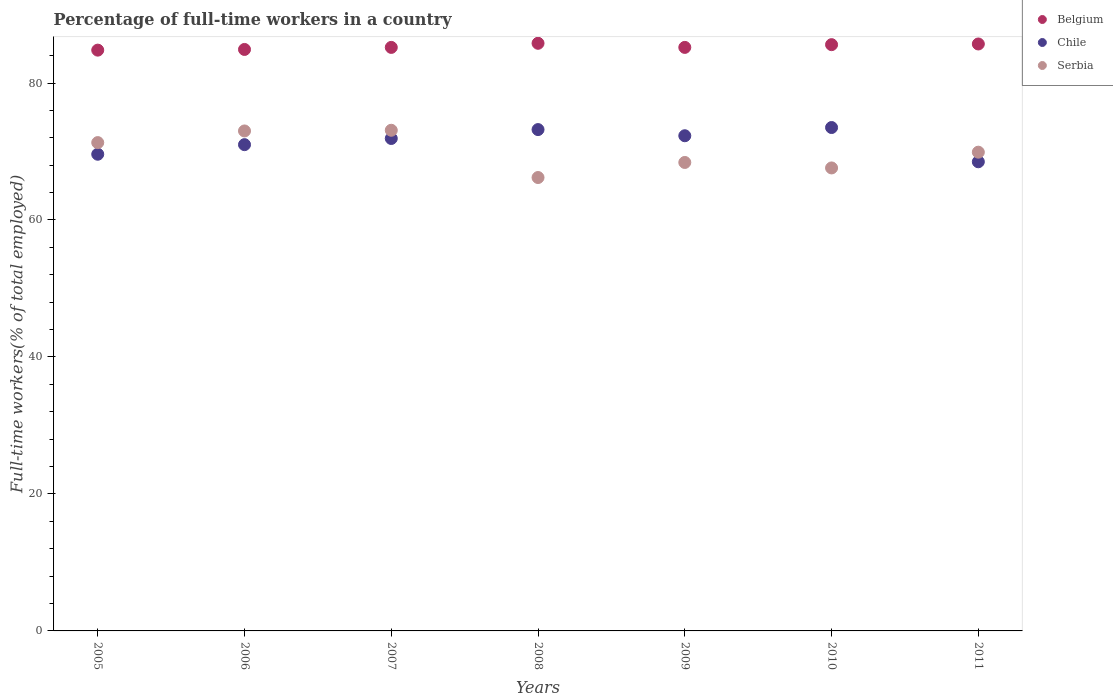How many different coloured dotlines are there?
Offer a very short reply. 3. Is the number of dotlines equal to the number of legend labels?
Provide a succinct answer. Yes. What is the percentage of full-time workers in Chile in 2005?
Offer a terse response. 69.6. Across all years, what is the maximum percentage of full-time workers in Serbia?
Offer a terse response. 73.1. Across all years, what is the minimum percentage of full-time workers in Serbia?
Offer a terse response. 66.2. In which year was the percentage of full-time workers in Serbia minimum?
Your answer should be very brief. 2008. What is the total percentage of full-time workers in Serbia in the graph?
Make the answer very short. 489.5. What is the difference between the percentage of full-time workers in Serbia in 2008 and that in 2010?
Your answer should be compact. -1.4. What is the difference between the percentage of full-time workers in Serbia in 2010 and the percentage of full-time workers in Chile in 2009?
Provide a succinct answer. -4.7. What is the average percentage of full-time workers in Serbia per year?
Offer a very short reply. 69.93. In the year 2006, what is the difference between the percentage of full-time workers in Belgium and percentage of full-time workers in Chile?
Offer a terse response. 13.9. What is the ratio of the percentage of full-time workers in Belgium in 2007 to that in 2009?
Offer a very short reply. 1. Is the difference between the percentage of full-time workers in Belgium in 2008 and 2009 greater than the difference between the percentage of full-time workers in Chile in 2008 and 2009?
Your response must be concise. No. What is the difference between the highest and the second highest percentage of full-time workers in Chile?
Give a very brief answer. 0.3. What is the difference between the highest and the lowest percentage of full-time workers in Serbia?
Provide a succinct answer. 6.9. In how many years, is the percentage of full-time workers in Belgium greater than the average percentage of full-time workers in Belgium taken over all years?
Offer a terse response. 3. How many years are there in the graph?
Your answer should be very brief. 7. Are the values on the major ticks of Y-axis written in scientific E-notation?
Your answer should be compact. No. Does the graph contain any zero values?
Offer a very short reply. No. Where does the legend appear in the graph?
Ensure brevity in your answer.  Top right. How are the legend labels stacked?
Offer a terse response. Vertical. What is the title of the graph?
Your answer should be compact. Percentage of full-time workers in a country. What is the label or title of the Y-axis?
Ensure brevity in your answer.  Full-time workers(% of total employed). What is the Full-time workers(% of total employed) of Belgium in 2005?
Make the answer very short. 84.8. What is the Full-time workers(% of total employed) of Chile in 2005?
Provide a succinct answer. 69.6. What is the Full-time workers(% of total employed) of Serbia in 2005?
Offer a very short reply. 71.3. What is the Full-time workers(% of total employed) of Belgium in 2006?
Keep it short and to the point. 84.9. What is the Full-time workers(% of total employed) of Serbia in 2006?
Your answer should be compact. 73. What is the Full-time workers(% of total employed) in Belgium in 2007?
Provide a short and direct response. 85.2. What is the Full-time workers(% of total employed) in Chile in 2007?
Provide a succinct answer. 71.9. What is the Full-time workers(% of total employed) of Serbia in 2007?
Keep it short and to the point. 73.1. What is the Full-time workers(% of total employed) in Belgium in 2008?
Your response must be concise. 85.8. What is the Full-time workers(% of total employed) of Chile in 2008?
Provide a succinct answer. 73.2. What is the Full-time workers(% of total employed) in Serbia in 2008?
Make the answer very short. 66.2. What is the Full-time workers(% of total employed) of Belgium in 2009?
Your response must be concise. 85.2. What is the Full-time workers(% of total employed) of Chile in 2009?
Offer a very short reply. 72.3. What is the Full-time workers(% of total employed) of Serbia in 2009?
Make the answer very short. 68.4. What is the Full-time workers(% of total employed) of Belgium in 2010?
Your response must be concise. 85.6. What is the Full-time workers(% of total employed) of Chile in 2010?
Your answer should be very brief. 73.5. What is the Full-time workers(% of total employed) of Serbia in 2010?
Your answer should be very brief. 67.6. What is the Full-time workers(% of total employed) in Belgium in 2011?
Provide a succinct answer. 85.7. What is the Full-time workers(% of total employed) in Chile in 2011?
Your response must be concise. 68.5. What is the Full-time workers(% of total employed) of Serbia in 2011?
Provide a short and direct response. 69.9. Across all years, what is the maximum Full-time workers(% of total employed) in Belgium?
Keep it short and to the point. 85.8. Across all years, what is the maximum Full-time workers(% of total employed) of Chile?
Provide a short and direct response. 73.5. Across all years, what is the maximum Full-time workers(% of total employed) of Serbia?
Ensure brevity in your answer.  73.1. Across all years, what is the minimum Full-time workers(% of total employed) of Belgium?
Make the answer very short. 84.8. Across all years, what is the minimum Full-time workers(% of total employed) of Chile?
Your response must be concise. 68.5. Across all years, what is the minimum Full-time workers(% of total employed) of Serbia?
Provide a succinct answer. 66.2. What is the total Full-time workers(% of total employed) of Belgium in the graph?
Ensure brevity in your answer.  597.2. What is the total Full-time workers(% of total employed) of Chile in the graph?
Ensure brevity in your answer.  500. What is the total Full-time workers(% of total employed) in Serbia in the graph?
Your answer should be very brief. 489.5. What is the difference between the Full-time workers(% of total employed) in Belgium in 2005 and that in 2007?
Offer a terse response. -0.4. What is the difference between the Full-time workers(% of total employed) in Serbia in 2005 and that in 2007?
Provide a short and direct response. -1.8. What is the difference between the Full-time workers(% of total employed) in Chile in 2005 and that in 2008?
Keep it short and to the point. -3.6. What is the difference between the Full-time workers(% of total employed) of Serbia in 2005 and that in 2008?
Keep it short and to the point. 5.1. What is the difference between the Full-time workers(% of total employed) of Belgium in 2005 and that in 2009?
Make the answer very short. -0.4. What is the difference between the Full-time workers(% of total employed) of Belgium in 2005 and that in 2010?
Your answer should be compact. -0.8. What is the difference between the Full-time workers(% of total employed) of Chile in 2005 and that in 2010?
Your answer should be compact. -3.9. What is the difference between the Full-time workers(% of total employed) in Belgium in 2005 and that in 2011?
Your response must be concise. -0.9. What is the difference between the Full-time workers(% of total employed) of Belgium in 2006 and that in 2007?
Give a very brief answer. -0.3. What is the difference between the Full-time workers(% of total employed) of Chile in 2006 and that in 2007?
Offer a terse response. -0.9. What is the difference between the Full-time workers(% of total employed) of Belgium in 2006 and that in 2008?
Make the answer very short. -0.9. What is the difference between the Full-time workers(% of total employed) of Serbia in 2006 and that in 2008?
Offer a terse response. 6.8. What is the difference between the Full-time workers(% of total employed) in Belgium in 2006 and that in 2010?
Provide a succinct answer. -0.7. What is the difference between the Full-time workers(% of total employed) of Serbia in 2006 and that in 2010?
Provide a succinct answer. 5.4. What is the difference between the Full-time workers(% of total employed) of Belgium in 2006 and that in 2011?
Keep it short and to the point. -0.8. What is the difference between the Full-time workers(% of total employed) of Chile in 2006 and that in 2011?
Ensure brevity in your answer.  2.5. What is the difference between the Full-time workers(% of total employed) in Serbia in 2006 and that in 2011?
Your answer should be very brief. 3.1. What is the difference between the Full-time workers(% of total employed) of Belgium in 2007 and that in 2008?
Your answer should be very brief. -0.6. What is the difference between the Full-time workers(% of total employed) in Chile in 2007 and that in 2008?
Offer a terse response. -1.3. What is the difference between the Full-time workers(% of total employed) in Belgium in 2007 and that in 2009?
Your answer should be compact. 0. What is the difference between the Full-time workers(% of total employed) of Belgium in 2007 and that in 2010?
Your answer should be compact. -0.4. What is the difference between the Full-time workers(% of total employed) in Belgium in 2007 and that in 2011?
Provide a succinct answer. -0.5. What is the difference between the Full-time workers(% of total employed) in Chile in 2008 and that in 2009?
Offer a very short reply. 0.9. What is the difference between the Full-time workers(% of total employed) of Belgium in 2008 and that in 2010?
Offer a very short reply. 0.2. What is the difference between the Full-time workers(% of total employed) of Serbia in 2008 and that in 2010?
Provide a short and direct response. -1.4. What is the difference between the Full-time workers(% of total employed) of Belgium in 2009 and that in 2010?
Provide a short and direct response. -0.4. What is the difference between the Full-time workers(% of total employed) in Chile in 2009 and that in 2010?
Offer a terse response. -1.2. What is the difference between the Full-time workers(% of total employed) of Belgium in 2009 and that in 2011?
Make the answer very short. -0.5. What is the difference between the Full-time workers(% of total employed) of Chile in 2009 and that in 2011?
Provide a succinct answer. 3.8. What is the difference between the Full-time workers(% of total employed) of Serbia in 2009 and that in 2011?
Your response must be concise. -1.5. What is the difference between the Full-time workers(% of total employed) of Belgium in 2010 and that in 2011?
Provide a succinct answer. -0.1. What is the difference between the Full-time workers(% of total employed) in Belgium in 2005 and the Full-time workers(% of total employed) in Chile in 2006?
Provide a short and direct response. 13.8. What is the difference between the Full-time workers(% of total employed) in Belgium in 2005 and the Full-time workers(% of total employed) in Serbia in 2006?
Give a very brief answer. 11.8. What is the difference between the Full-time workers(% of total employed) in Belgium in 2005 and the Full-time workers(% of total employed) in Serbia in 2008?
Offer a very short reply. 18.6. What is the difference between the Full-time workers(% of total employed) in Chile in 2005 and the Full-time workers(% of total employed) in Serbia in 2008?
Offer a terse response. 3.4. What is the difference between the Full-time workers(% of total employed) in Belgium in 2005 and the Full-time workers(% of total employed) in Chile in 2009?
Offer a very short reply. 12.5. What is the difference between the Full-time workers(% of total employed) in Belgium in 2005 and the Full-time workers(% of total employed) in Serbia in 2009?
Make the answer very short. 16.4. What is the difference between the Full-time workers(% of total employed) of Chile in 2005 and the Full-time workers(% of total employed) of Serbia in 2009?
Provide a succinct answer. 1.2. What is the difference between the Full-time workers(% of total employed) of Chile in 2005 and the Full-time workers(% of total employed) of Serbia in 2011?
Provide a short and direct response. -0.3. What is the difference between the Full-time workers(% of total employed) of Belgium in 2006 and the Full-time workers(% of total employed) of Chile in 2007?
Your answer should be compact. 13. What is the difference between the Full-time workers(% of total employed) in Belgium in 2006 and the Full-time workers(% of total employed) in Serbia in 2007?
Ensure brevity in your answer.  11.8. What is the difference between the Full-time workers(% of total employed) of Chile in 2006 and the Full-time workers(% of total employed) of Serbia in 2007?
Keep it short and to the point. -2.1. What is the difference between the Full-time workers(% of total employed) of Belgium in 2006 and the Full-time workers(% of total employed) of Chile in 2008?
Your response must be concise. 11.7. What is the difference between the Full-time workers(% of total employed) in Belgium in 2006 and the Full-time workers(% of total employed) in Serbia in 2008?
Provide a short and direct response. 18.7. What is the difference between the Full-time workers(% of total employed) of Chile in 2006 and the Full-time workers(% of total employed) of Serbia in 2008?
Your response must be concise. 4.8. What is the difference between the Full-time workers(% of total employed) of Belgium in 2006 and the Full-time workers(% of total employed) of Serbia in 2009?
Your answer should be compact. 16.5. What is the difference between the Full-time workers(% of total employed) in Belgium in 2006 and the Full-time workers(% of total employed) in Chile in 2010?
Offer a very short reply. 11.4. What is the difference between the Full-time workers(% of total employed) of Belgium in 2006 and the Full-time workers(% of total employed) of Serbia in 2010?
Provide a succinct answer. 17.3. What is the difference between the Full-time workers(% of total employed) of Chile in 2006 and the Full-time workers(% of total employed) of Serbia in 2010?
Give a very brief answer. 3.4. What is the difference between the Full-time workers(% of total employed) in Belgium in 2006 and the Full-time workers(% of total employed) in Chile in 2011?
Provide a succinct answer. 16.4. What is the difference between the Full-time workers(% of total employed) of Belgium in 2006 and the Full-time workers(% of total employed) of Serbia in 2011?
Offer a terse response. 15. What is the difference between the Full-time workers(% of total employed) in Chile in 2006 and the Full-time workers(% of total employed) in Serbia in 2011?
Your answer should be compact. 1.1. What is the difference between the Full-time workers(% of total employed) of Belgium in 2007 and the Full-time workers(% of total employed) of Chile in 2008?
Your answer should be compact. 12. What is the difference between the Full-time workers(% of total employed) of Belgium in 2007 and the Full-time workers(% of total employed) of Serbia in 2009?
Provide a succinct answer. 16.8. What is the difference between the Full-time workers(% of total employed) of Chile in 2007 and the Full-time workers(% of total employed) of Serbia in 2010?
Give a very brief answer. 4.3. What is the difference between the Full-time workers(% of total employed) in Belgium in 2008 and the Full-time workers(% of total employed) in Serbia in 2009?
Your answer should be very brief. 17.4. What is the difference between the Full-time workers(% of total employed) in Belgium in 2008 and the Full-time workers(% of total employed) in Chile in 2011?
Make the answer very short. 17.3. What is the difference between the Full-time workers(% of total employed) of Chile in 2008 and the Full-time workers(% of total employed) of Serbia in 2011?
Offer a terse response. 3.3. What is the difference between the Full-time workers(% of total employed) in Belgium in 2009 and the Full-time workers(% of total employed) in Chile in 2010?
Your answer should be compact. 11.7. What is the difference between the Full-time workers(% of total employed) in Belgium in 2009 and the Full-time workers(% of total employed) in Serbia in 2011?
Make the answer very short. 15.3. What is the difference between the Full-time workers(% of total employed) of Chile in 2010 and the Full-time workers(% of total employed) of Serbia in 2011?
Ensure brevity in your answer.  3.6. What is the average Full-time workers(% of total employed) of Belgium per year?
Your answer should be compact. 85.31. What is the average Full-time workers(% of total employed) of Chile per year?
Provide a short and direct response. 71.43. What is the average Full-time workers(% of total employed) in Serbia per year?
Your answer should be compact. 69.93. In the year 2005, what is the difference between the Full-time workers(% of total employed) in Chile and Full-time workers(% of total employed) in Serbia?
Provide a succinct answer. -1.7. In the year 2006, what is the difference between the Full-time workers(% of total employed) of Belgium and Full-time workers(% of total employed) of Serbia?
Make the answer very short. 11.9. In the year 2008, what is the difference between the Full-time workers(% of total employed) of Belgium and Full-time workers(% of total employed) of Chile?
Your answer should be compact. 12.6. In the year 2008, what is the difference between the Full-time workers(% of total employed) in Belgium and Full-time workers(% of total employed) in Serbia?
Offer a very short reply. 19.6. In the year 2009, what is the difference between the Full-time workers(% of total employed) of Chile and Full-time workers(% of total employed) of Serbia?
Offer a very short reply. 3.9. In the year 2010, what is the difference between the Full-time workers(% of total employed) in Belgium and Full-time workers(% of total employed) in Chile?
Offer a terse response. 12.1. In the year 2010, what is the difference between the Full-time workers(% of total employed) of Belgium and Full-time workers(% of total employed) of Serbia?
Make the answer very short. 18. In the year 2011, what is the difference between the Full-time workers(% of total employed) of Belgium and Full-time workers(% of total employed) of Chile?
Your answer should be very brief. 17.2. What is the ratio of the Full-time workers(% of total employed) in Belgium in 2005 to that in 2006?
Ensure brevity in your answer.  1. What is the ratio of the Full-time workers(% of total employed) in Chile in 2005 to that in 2006?
Your answer should be compact. 0.98. What is the ratio of the Full-time workers(% of total employed) in Serbia in 2005 to that in 2006?
Your response must be concise. 0.98. What is the ratio of the Full-time workers(% of total employed) of Belgium in 2005 to that in 2007?
Provide a short and direct response. 1. What is the ratio of the Full-time workers(% of total employed) in Serbia in 2005 to that in 2007?
Provide a succinct answer. 0.98. What is the ratio of the Full-time workers(% of total employed) of Belgium in 2005 to that in 2008?
Your response must be concise. 0.99. What is the ratio of the Full-time workers(% of total employed) in Chile in 2005 to that in 2008?
Your answer should be compact. 0.95. What is the ratio of the Full-time workers(% of total employed) in Serbia in 2005 to that in 2008?
Your answer should be compact. 1.08. What is the ratio of the Full-time workers(% of total employed) of Chile in 2005 to that in 2009?
Offer a terse response. 0.96. What is the ratio of the Full-time workers(% of total employed) in Serbia in 2005 to that in 2009?
Offer a terse response. 1.04. What is the ratio of the Full-time workers(% of total employed) in Belgium in 2005 to that in 2010?
Your answer should be compact. 0.99. What is the ratio of the Full-time workers(% of total employed) of Chile in 2005 to that in 2010?
Keep it short and to the point. 0.95. What is the ratio of the Full-time workers(% of total employed) in Serbia in 2005 to that in 2010?
Your answer should be compact. 1.05. What is the ratio of the Full-time workers(% of total employed) of Belgium in 2005 to that in 2011?
Give a very brief answer. 0.99. What is the ratio of the Full-time workers(% of total employed) of Chile in 2005 to that in 2011?
Your answer should be compact. 1.02. What is the ratio of the Full-time workers(% of total employed) in Belgium in 2006 to that in 2007?
Keep it short and to the point. 1. What is the ratio of the Full-time workers(% of total employed) in Chile in 2006 to that in 2007?
Make the answer very short. 0.99. What is the ratio of the Full-time workers(% of total employed) in Chile in 2006 to that in 2008?
Provide a short and direct response. 0.97. What is the ratio of the Full-time workers(% of total employed) of Serbia in 2006 to that in 2008?
Provide a short and direct response. 1.1. What is the ratio of the Full-time workers(% of total employed) in Belgium in 2006 to that in 2009?
Your answer should be very brief. 1. What is the ratio of the Full-time workers(% of total employed) in Serbia in 2006 to that in 2009?
Make the answer very short. 1.07. What is the ratio of the Full-time workers(% of total employed) in Chile in 2006 to that in 2010?
Your answer should be very brief. 0.97. What is the ratio of the Full-time workers(% of total employed) in Serbia in 2006 to that in 2010?
Provide a short and direct response. 1.08. What is the ratio of the Full-time workers(% of total employed) in Belgium in 2006 to that in 2011?
Your answer should be very brief. 0.99. What is the ratio of the Full-time workers(% of total employed) in Chile in 2006 to that in 2011?
Keep it short and to the point. 1.04. What is the ratio of the Full-time workers(% of total employed) in Serbia in 2006 to that in 2011?
Provide a succinct answer. 1.04. What is the ratio of the Full-time workers(% of total employed) of Chile in 2007 to that in 2008?
Ensure brevity in your answer.  0.98. What is the ratio of the Full-time workers(% of total employed) of Serbia in 2007 to that in 2008?
Offer a very short reply. 1.1. What is the ratio of the Full-time workers(% of total employed) in Chile in 2007 to that in 2009?
Your answer should be very brief. 0.99. What is the ratio of the Full-time workers(% of total employed) of Serbia in 2007 to that in 2009?
Your response must be concise. 1.07. What is the ratio of the Full-time workers(% of total employed) in Chile in 2007 to that in 2010?
Ensure brevity in your answer.  0.98. What is the ratio of the Full-time workers(% of total employed) in Serbia in 2007 to that in 2010?
Offer a very short reply. 1.08. What is the ratio of the Full-time workers(% of total employed) in Chile in 2007 to that in 2011?
Make the answer very short. 1.05. What is the ratio of the Full-time workers(% of total employed) in Serbia in 2007 to that in 2011?
Provide a short and direct response. 1.05. What is the ratio of the Full-time workers(% of total employed) of Belgium in 2008 to that in 2009?
Make the answer very short. 1.01. What is the ratio of the Full-time workers(% of total employed) in Chile in 2008 to that in 2009?
Offer a terse response. 1.01. What is the ratio of the Full-time workers(% of total employed) in Serbia in 2008 to that in 2009?
Offer a very short reply. 0.97. What is the ratio of the Full-time workers(% of total employed) of Belgium in 2008 to that in 2010?
Your answer should be very brief. 1. What is the ratio of the Full-time workers(% of total employed) of Chile in 2008 to that in 2010?
Provide a short and direct response. 1. What is the ratio of the Full-time workers(% of total employed) in Serbia in 2008 to that in 2010?
Provide a short and direct response. 0.98. What is the ratio of the Full-time workers(% of total employed) of Belgium in 2008 to that in 2011?
Offer a terse response. 1. What is the ratio of the Full-time workers(% of total employed) in Chile in 2008 to that in 2011?
Your answer should be compact. 1.07. What is the ratio of the Full-time workers(% of total employed) of Serbia in 2008 to that in 2011?
Your answer should be compact. 0.95. What is the ratio of the Full-time workers(% of total employed) of Chile in 2009 to that in 2010?
Ensure brevity in your answer.  0.98. What is the ratio of the Full-time workers(% of total employed) of Serbia in 2009 to that in 2010?
Your answer should be compact. 1.01. What is the ratio of the Full-time workers(% of total employed) in Belgium in 2009 to that in 2011?
Provide a short and direct response. 0.99. What is the ratio of the Full-time workers(% of total employed) of Chile in 2009 to that in 2011?
Give a very brief answer. 1.06. What is the ratio of the Full-time workers(% of total employed) in Serbia in 2009 to that in 2011?
Your answer should be very brief. 0.98. What is the ratio of the Full-time workers(% of total employed) of Chile in 2010 to that in 2011?
Provide a short and direct response. 1.07. What is the ratio of the Full-time workers(% of total employed) in Serbia in 2010 to that in 2011?
Offer a very short reply. 0.97. What is the difference between the highest and the lowest Full-time workers(% of total employed) of Chile?
Ensure brevity in your answer.  5. What is the difference between the highest and the lowest Full-time workers(% of total employed) of Serbia?
Give a very brief answer. 6.9. 